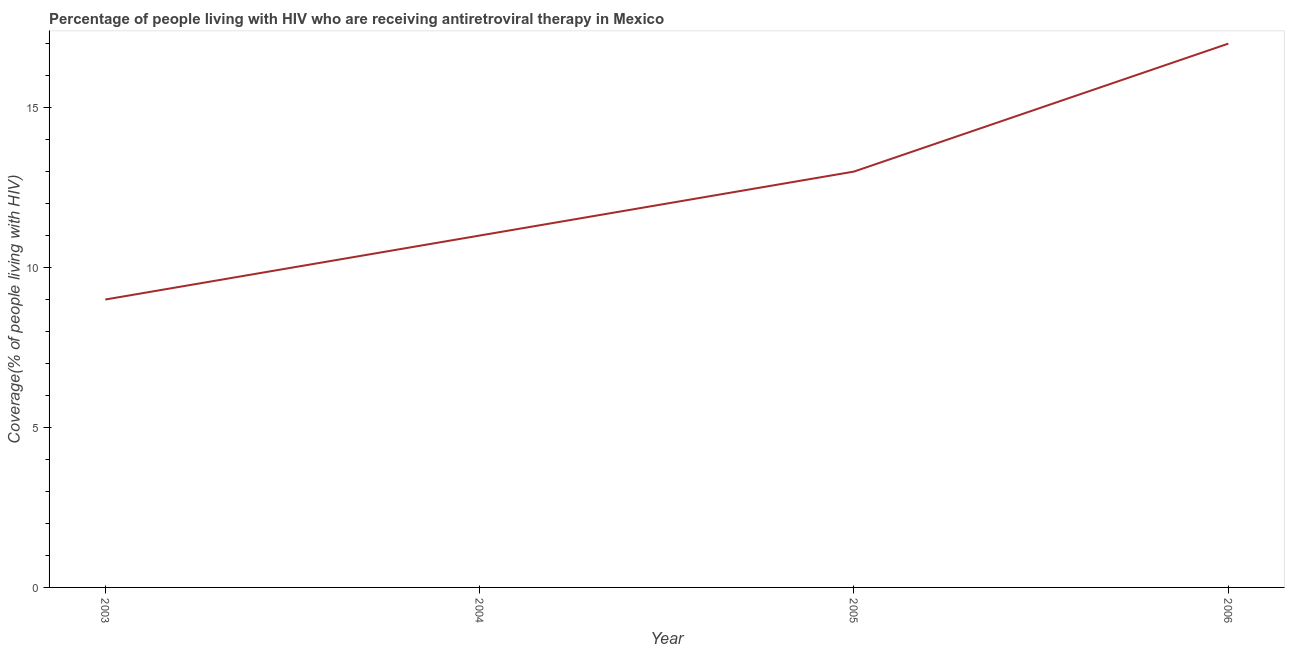What is the antiretroviral therapy coverage in 2004?
Ensure brevity in your answer.  11. Across all years, what is the maximum antiretroviral therapy coverage?
Your response must be concise. 17. Across all years, what is the minimum antiretroviral therapy coverage?
Provide a succinct answer. 9. What is the sum of the antiretroviral therapy coverage?
Keep it short and to the point. 50. What is the difference between the antiretroviral therapy coverage in 2004 and 2005?
Provide a succinct answer. -2. What is the average antiretroviral therapy coverage per year?
Your answer should be very brief. 12.5. What is the ratio of the antiretroviral therapy coverage in 2004 to that in 2005?
Give a very brief answer. 0.85. Is the antiretroviral therapy coverage in 2005 less than that in 2006?
Offer a terse response. Yes. Is the difference between the antiretroviral therapy coverage in 2005 and 2006 greater than the difference between any two years?
Your answer should be very brief. No. What is the difference between the highest and the lowest antiretroviral therapy coverage?
Make the answer very short. 8. What is the difference between two consecutive major ticks on the Y-axis?
Give a very brief answer. 5. Are the values on the major ticks of Y-axis written in scientific E-notation?
Offer a very short reply. No. What is the title of the graph?
Give a very brief answer. Percentage of people living with HIV who are receiving antiretroviral therapy in Mexico. What is the label or title of the X-axis?
Give a very brief answer. Year. What is the label or title of the Y-axis?
Offer a terse response. Coverage(% of people living with HIV). What is the Coverage(% of people living with HIV) of 2003?
Keep it short and to the point. 9. What is the Coverage(% of people living with HIV) of 2004?
Make the answer very short. 11. What is the difference between the Coverage(% of people living with HIV) in 2003 and 2006?
Provide a short and direct response. -8. What is the difference between the Coverage(% of people living with HIV) in 2004 and 2006?
Your response must be concise. -6. What is the difference between the Coverage(% of people living with HIV) in 2005 and 2006?
Give a very brief answer. -4. What is the ratio of the Coverage(% of people living with HIV) in 2003 to that in 2004?
Offer a very short reply. 0.82. What is the ratio of the Coverage(% of people living with HIV) in 2003 to that in 2005?
Keep it short and to the point. 0.69. What is the ratio of the Coverage(% of people living with HIV) in 2003 to that in 2006?
Keep it short and to the point. 0.53. What is the ratio of the Coverage(% of people living with HIV) in 2004 to that in 2005?
Provide a succinct answer. 0.85. What is the ratio of the Coverage(% of people living with HIV) in 2004 to that in 2006?
Ensure brevity in your answer.  0.65. What is the ratio of the Coverage(% of people living with HIV) in 2005 to that in 2006?
Offer a terse response. 0.77. 